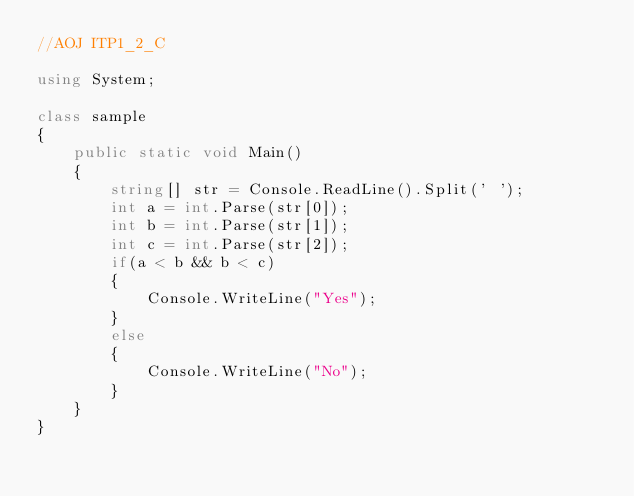<code> <loc_0><loc_0><loc_500><loc_500><_C#_>//AOJ ITP1_2_C

using System;

class sample
{
    public static void Main()
    {
        string[] str = Console.ReadLine().Split(' ');
        int a = int.Parse(str[0]);
        int b = int.Parse(str[1]);
        int c = int.Parse(str[2]);
        if(a < b && b < c)
        {
            Console.WriteLine("Yes");
        }
        else
        {
            Console.WriteLine("No");
        }
    }
}</code> 